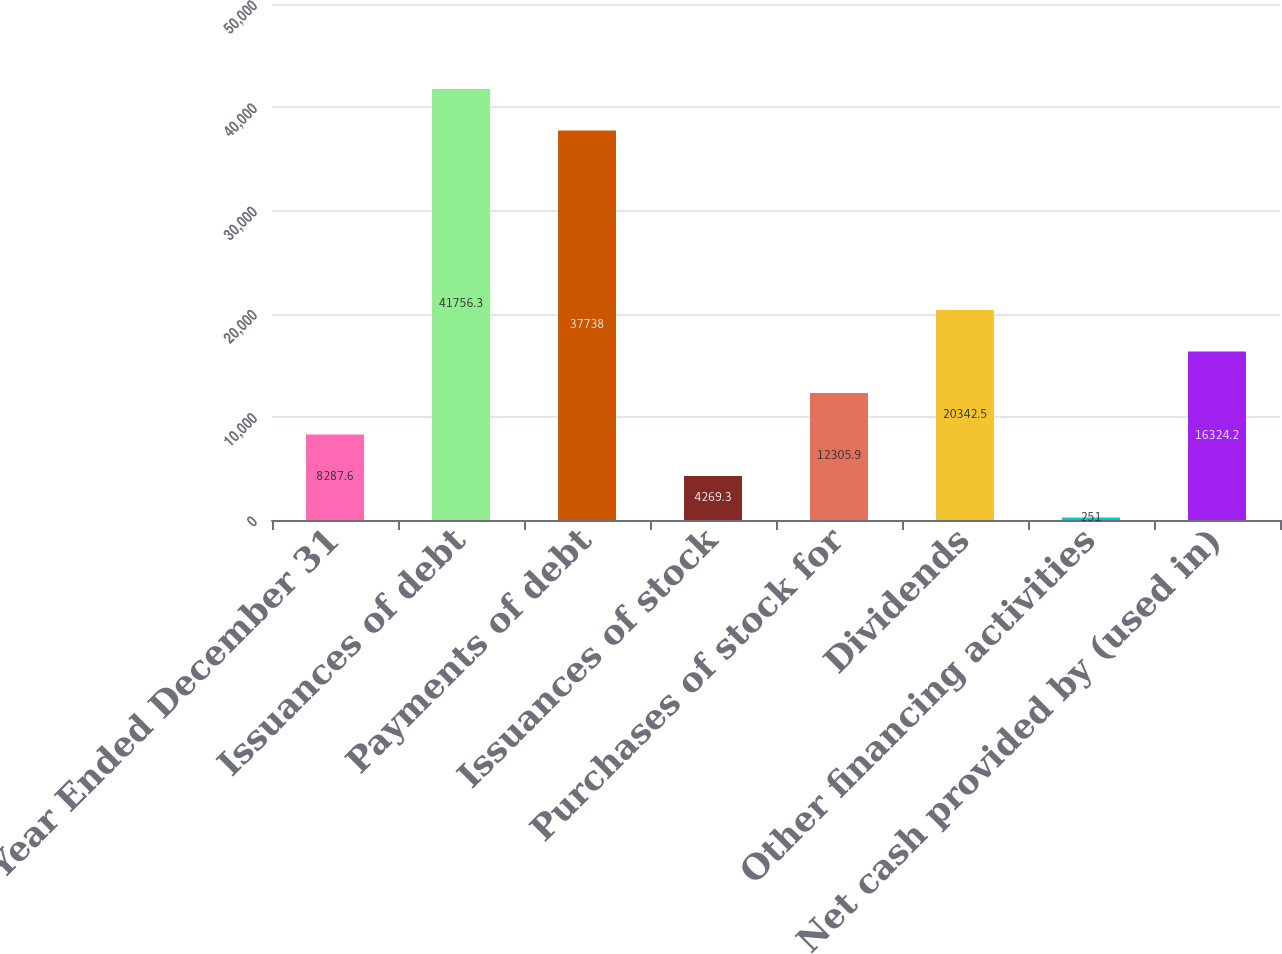Convert chart to OTSL. <chart><loc_0><loc_0><loc_500><loc_500><bar_chart><fcel>Year Ended December 31<fcel>Issuances of debt<fcel>Payments of debt<fcel>Issuances of stock<fcel>Purchases of stock for<fcel>Dividends<fcel>Other financing activities<fcel>Net cash provided by (used in)<nl><fcel>8287.6<fcel>41756.3<fcel>37738<fcel>4269.3<fcel>12305.9<fcel>20342.5<fcel>251<fcel>16324.2<nl></chart> 